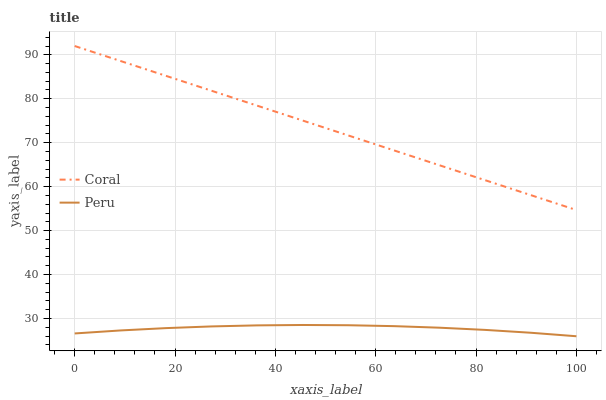Does Peru have the minimum area under the curve?
Answer yes or no. Yes. Does Coral have the maximum area under the curve?
Answer yes or no. Yes. Does Peru have the maximum area under the curve?
Answer yes or no. No. Is Coral the smoothest?
Answer yes or no. Yes. Is Peru the roughest?
Answer yes or no. Yes. Is Peru the smoothest?
Answer yes or no. No. Does Peru have the highest value?
Answer yes or no. No. Is Peru less than Coral?
Answer yes or no. Yes. Is Coral greater than Peru?
Answer yes or no. Yes. Does Peru intersect Coral?
Answer yes or no. No. 